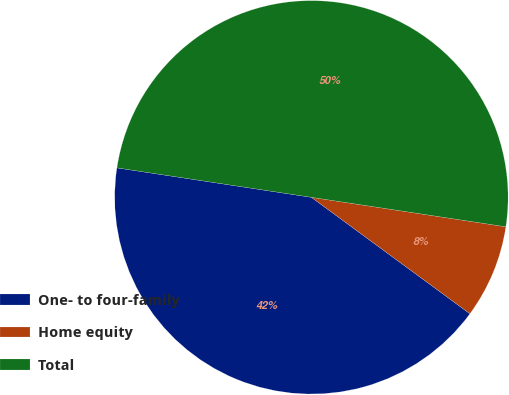Convert chart to OTSL. <chart><loc_0><loc_0><loc_500><loc_500><pie_chart><fcel>One- to four-family<fcel>Home equity<fcel>Total<nl><fcel>42.31%<fcel>7.69%<fcel>50.0%<nl></chart> 